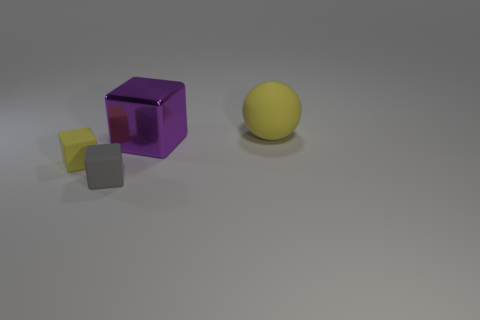Add 1 small brown cylinders. How many objects exist? 5 Subtract all blocks. How many objects are left? 1 Add 1 big purple metal objects. How many big purple metal objects are left? 2 Add 4 yellow matte things. How many yellow matte things exist? 6 Subtract 1 purple blocks. How many objects are left? 3 Subtract all tiny yellow blocks. Subtract all big matte things. How many objects are left? 2 